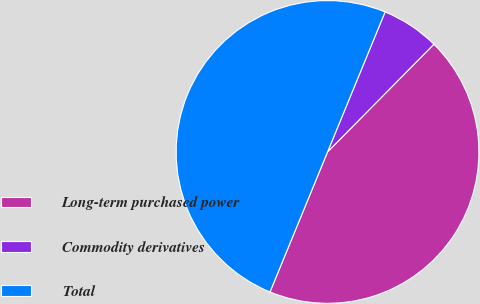<chart> <loc_0><loc_0><loc_500><loc_500><pie_chart><fcel>Long-term purchased power<fcel>Commodity derivatives<fcel>Total<nl><fcel>43.81%<fcel>6.19%<fcel>50.0%<nl></chart> 